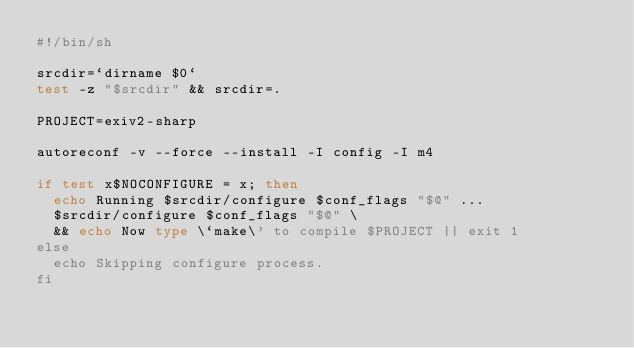Convert code to text. <code><loc_0><loc_0><loc_500><loc_500><_Bash_>#!/bin/sh

srcdir=`dirname $0`
test -z "$srcdir" && srcdir=.

PROJECT=exiv2-sharp

autoreconf -v --force --install -I config -I m4

if test x$NOCONFIGURE = x; then
  echo Running $srcdir/configure $conf_flags "$@" ...
  $srcdir/configure $conf_flags "$@" \
  && echo Now type \`make\' to compile $PROJECT || exit 1
else
  echo Skipping configure process.
fi

</code> 